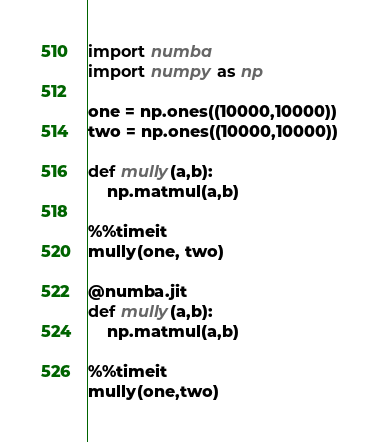Convert code to text. <code><loc_0><loc_0><loc_500><loc_500><_Python_>import numba
import numpy as np

one = np.ones((10000,10000))
two = np.ones((10000,10000))

def mully(a,b):
    np.matmul(a,b)

%%timeit
mully(one, two)

@numba.jit
def mully(a,b):
    np.matmul(a,b)

%%timeit
mully(one,two)
</code> 